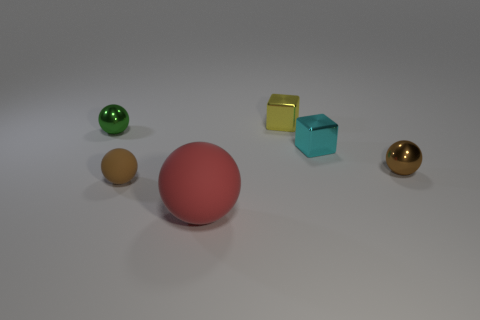Subtract 1 spheres. How many spheres are left? 3 Add 2 red matte cylinders. How many objects exist? 8 Subtract all cubes. How many objects are left? 4 Subtract 0 yellow spheres. How many objects are left? 6 Subtract all tiny cyan metallic blocks. Subtract all small yellow objects. How many objects are left? 4 Add 5 red rubber objects. How many red rubber objects are left? 6 Add 4 cyan objects. How many cyan objects exist? 5 